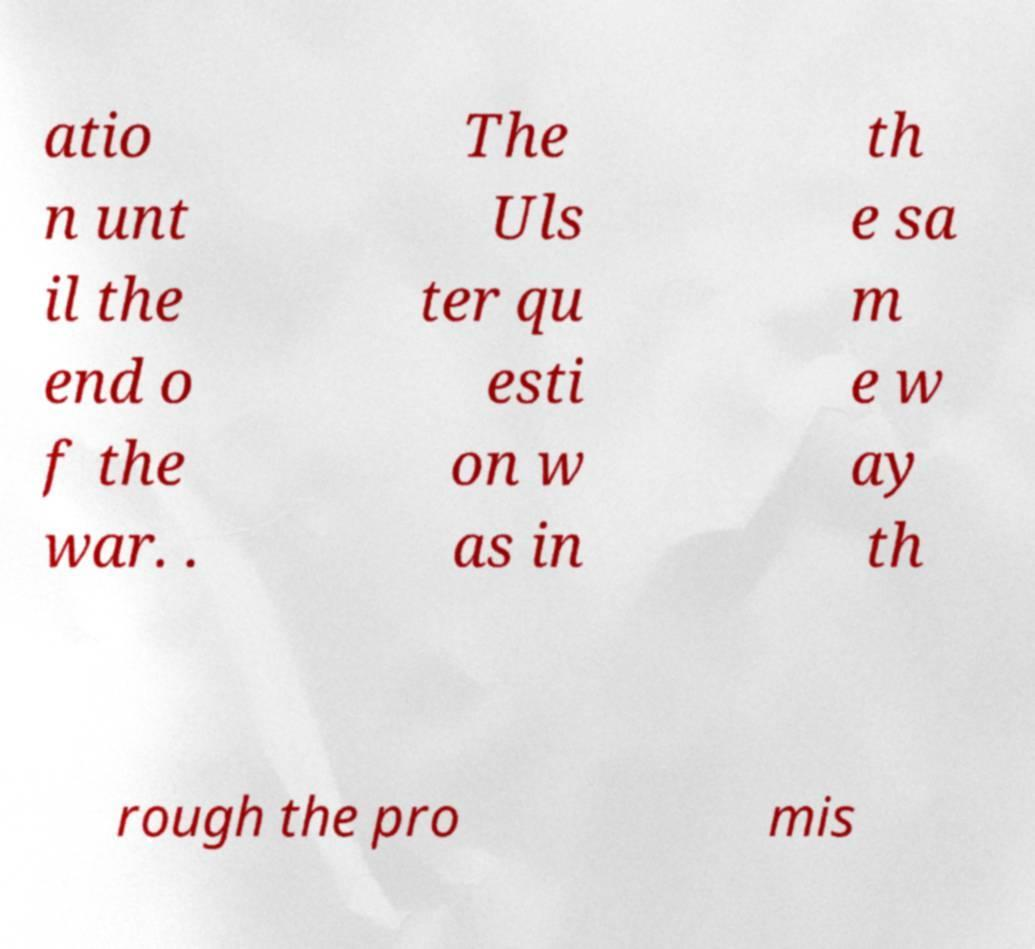Could you extract and type out the text from this image? atio n unt il the end o f the war. . The Uls ter qu esti on w as in th e sa m e w ay th rough the pro mis 